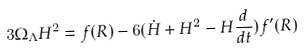<formula> <loc_0><loc_0><loc_500><loc_500>3 \Omega _ { \Lambda } H ^ { 2 } = f ( R ) - 6 ( \dot { H } + H ^ { 2 } - H \frac { d } { d t } ) f ^ { \prime } ( R )</formula> 